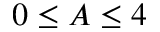Convert formula to latex. <formula><loc_0><loc_0><loc_500><loc_500>0 \leq A \leq 4</formula> 